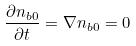<formula> <loc_0><loc_0><loc_500><loc_500>\frac { \partial n _ { b 0 } } { \partial t } = \nabla n _ { b 0 } = 0</formula> 